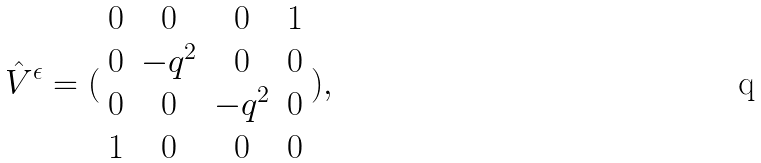Convert formula to latex. <formula><loc_0><loc_0><loc_500><loc_500>\hat { V } ^ { \epsilon } = ( \begin{array} { c c c c } 0 & 0 & 0 & 1 \\ 0 & - q ^ { 2 } & 0 & 0 \\ 0 & 0 & - q ^ { 2 } & 0 \\ 1 & 0 & 0 & 0 \end{array} ) ,</formula> 